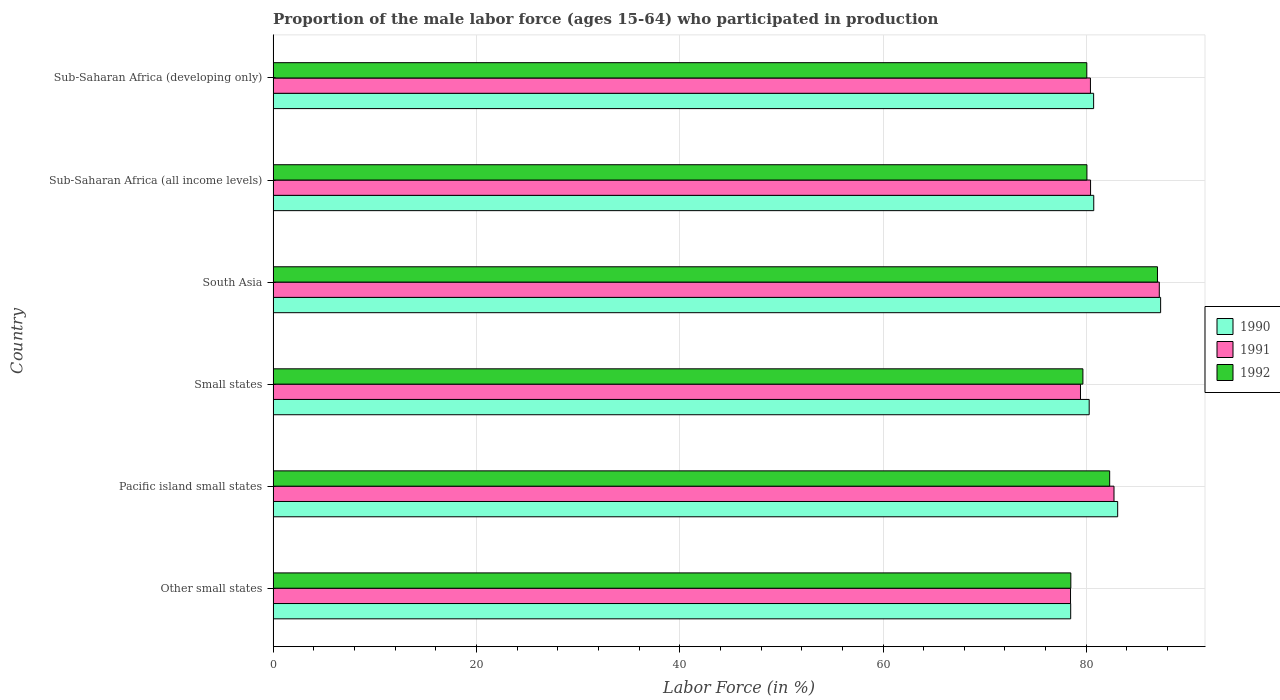How many different coloured bars are there?
Offer a very short reply. 3. Are the number of bars per tick equal to the number of legend labels?
Make the answer very short. Yes. How many bars are there on the 3rd tick from the top?
Offer a very short reply. 3. How many bars are there on the 5th tick from the bottom?
Your response must be concise. 3. What is the label of the 4th group of bars from the top?
Keep it short and to the point. Small states. In how many cases, is the number of bars for a given country not equal to the number of legend labels?
Provide a succinct answer. 0. What is the proportion of the male labor force who participated in production in 1992 in Sub-Saharan Africa (developing only)?
Provide a short and direct response. 80.05. Across all countries, what is the maximum proportion of the male labor force who participated in production in 1990?
Your answer should be compact. 87.31. Across all countries, what is the minimum proportion of the male labor force who participated in production in 1990?
Keep it short and to the point. 78.46. In which country was the proportion of the male labor force who participated in production in 1991 maximum?
Keep it short and to the point. South Asia. In which country was the proportion of the male labor force who participated in production in 1991 minimum?
Offer a terse response. Other small states. What is the total proportion of the male labor force who participated in production in 1992 in the graph?
Give a very brief answer. 487.55. What is the difference between the proportion of the male labor force who participated in production in 1990 in Small states and that in South Asia?
Offer a terse response. -7.03. What is the difference between the proportion of the male labor force who participated in production in 1990 in Pacific island small states and the proportion of the male labor force who participated in production in 1991 in Small states?
Make the answer very short. 3.66. What is the average proportion of the male labor force who participated in production in 1992 per country?
Your answer should be very brief. 81.26. What is the difference between the proportion of the male labor force who participated in production in 1991 and proportion of the male labor force who participated in production in 1992 in Sub-Saharan Africa (all income levels)?
Ensure brevity in your answer.  0.36. In how many countries, is the proportion of the male labor force who participated in production in 1992 greater than 36 %?
Ensure brevity in your answer.  6. What is the ratio of the proportion of the male labor force who participated in production in 1991 in Small states to that in South Asia?
Provide a succinct answer. 0.91. What is the difference between the highest and the second highest proportion of the male labor force who participated in production in 1990?
Make the answer very short. 4.22. What is the difference between the highest and the lowest proportion of the male labor force who participated in production in 1992?
Make the answer very short. 8.52. In how many countries, is the proportion of the male labor force who participated in production in 1992 greater than the average proportion of the male labor force who participated in production in 1992 taken over all countries?
Offer a terse response. 2. Is the sum of the proportion of the male labor force who participated in production in 1991 in Sub-Saharan Africa (all income levels) and Sub-Saharan Africa (developing only) greater than the maximum proportion of the male labor force who participated in production in 1992 across all countries?
Offer a terse response. Yes. What does the 2nd bar from the top in Sub-Saharan Africa (developing only) represents?
Make the answer very short. 1991. What does the 3rd bar from the bottom in Sub-Saharan Africa (developing only) represents?
Make the answer very short. 1992. How many bars are there?
Keep it short and to the point. 18. How many countries are there in the graph?
Give a very brief answer. 6. What is the difference between two consecutive major ticks on the X-axis?
Ensure brevity in your answer.  20. Are the values on the major ticks of X-axis written in scientific E-notation?
Your answer should be compact. No. Does the graph contain any zero values?
Offer a terse response. No. Does the graph contain grids?
Make the answer very short. Yes. What is the title of the graph?
Ensure brevity in your answer.  Proportion of the male labor force (ages 15-64) who participated in production. Does "1974" appear as one of the legend labels in the graph?
Offer a terse response. No. What is the label or title of the X-axis?
Offer a terse response. Labor Force (in %). What is the label or title of the Y-axis?
Your response must be concise. Country. What is the Labor Force (in %) in 1990 in Other small states?
Make the answer very short. 78.46. What is the Labor Force (in %) of 1991 in Other small states?
Provide a short and direct response. 78.45. What is the Labor Force (in %) of 1992 in Other small states?
Your answer should be very brief. 78.48. What is the Labor Force (in %) of 1990 in Pacific island small states?
Offer a very short reply. 83.09. What is the Labor Force (in %) in 1991 in Pacific island small states?
Your answer should be compact. 82.72. What is the Labor Force (in %) in 1992 in Pacific island small states?
Keep it short and to the point. 82.3. What is the Labor Force (in %) of 1990 in Small states?
Offer a terse response. 80.28. What is the Labor Force (in %) of 1991 in Small states?
Your answer should be compact. 79.43. What is the Labor Force (in %) in 1992 in Small states?
Offer a very short reply. 79.66. What is the Labor Force (in %) of 1990 in South Asia?
Your answer should be very brief. 87.31. What is the Labor Force (in %) of 1991 in South Asia?
Offer a terse response. 87.18. What is the Labor Force (in %) in 1992 in South Asia?
Your answer should be compact. 87. What is the Labor Force (in %) of 1990 in Sub-Saharan Africa (all income levels)?
Provide a succinct answer. 80.73. What is the Labor Force (in %) of 1991 in Sub-Saharan Africa (all income levels)?
Your answer should be very brief. 80.42. What is the Labor Force (in %) of 1992 in Sub-Saharan Africa (all income levels)?
Offer a terse response. 80.06. What is the Labor Force (in %) in 1990 in Sub-Saharan Africa (developing only)?
Ensure brevity in your answer.  80.72. What is the Labor Force (in %) in 1991 in Sub-Saharan Africa (developing only)?
Offer a terse response. 80.41. What is the Labor Force (in %) of 1992 in Sub-Saharan Africa (developing only)?
Give a very brief answer. 80.05. Across all countries, what is the maximum Labor Force (in %) of 1990?
Give a very brief answer. 87.31. Across all countries, what is the maximum Labor Force (in %) in 1991?
Ensure brevity in your answer.  87.18. Across all countries, what is the maximum Labor Force (in %) of 1992?
Your answer should be very brief. 87. Across all countries, what is the minimum Labor Force (in %) in 1990?
Ensure brevity in your answer.  78.46. Across all countries, what is the minimum Labor Force (in %) of 1991?
Offer a terse response. 78.45. Across all countries, what is the minimum Labor Force (in %) in 1992?
Your answer should be very brief. 78.48. What is the total Labor Force (in %) in 1990 in the graph?
Provide a short and direct response. 490.6. What is the total Labor Force (in %) in 1991 in the graph?
Make the answer very short. 488.6. What is the total Labor Force (in %) of 1992 in the graph?
Offer a terse response. 487.55. What is the difference between the Labor Force (in %) of 1990 in Other small states and that in Pacific island small states?
Offer a terse response. -4.62. What is the difference between the Labor Force (in %) in 1991 in Other small states and that in Pacific island small states?
Your answer should be compact. -4.28. What is the difference between the Labor Force (in %) in 1992 in Other small states and that in Pacific island small states?
Provide a short and direct response. -3.82. What is the difference between the Labor Force (in %) in 1990 in Other small states and that in Small states?
Your answer should be very brief. -1.82. What is the difference between the Labor Force (in %) of 1991 in Other small states and that in Small states?
Provide a succinct answer. -0.98. What is the difference between the Labor Force (in %) in 1992 in Other small states and that in Small states?
Provide a succinct answer. -1.19. What is the difference between the Labor Force (in %) of 1990 in Other small states and that in South Asia?
Provide a short and direct response. -8.85. What is the difference between the Labor Force (in %) in 1991 in Other small states and that in South Asia?
Provide a short and direct response. -8.73. What is the difference between the Labor Force (in %) in 1992 in Other small states and that in South Asia?
Offer a very short reply. -8.52. What is the difference between the Labor Force (in %) in 1990 in Other small states and that in Sub-Saharan Africa (all income levels)?
Provide a short and direct response. -2.27. What is the difference between the Labor Force (in %) of 1991 in Other small states and that in Sub-Saharan Africa (all income levels)?
Your answer should be very brief. -1.97. What is the difference between the Labor Force (in %) in 1992 in Other small states and that in Sub-Saharan Africa (all income levels)?
Your answer should be compact. -1.58. What is the difference between the Labor Force (in %) in 1990 in Other small states and that in Sub-Saharan Africa (developing only)?
Provide a short and direct response. -2.26. What is the difference between the Labor Force (in %) in 1991 in Other small states and that in Sub-Saharan Africa (developing only)?
Make the answer very short. -1.96. What is the difference between the Labor Force (in %) of 1992 in Other small states and that in Sub-Saharan Africa (developing only)?
Keep it short and to the point. -1.57. What is the difference between the Labor Force (in %) in 1990 in Pacific island small states and that in Small states?
Offer a very short reply. 2.8. What is the difference between the Labor Force (in %) of 1991 in Pacific island small states and that in Small states?
Your response must be concise. 3.3. What is the difference between the Labor Force (in %) in 1992 in Pacific island small states and that in Small states?
Make the answer very short. 2.63. What is the difference between the Labor Force (in %) of 1990 in Pacific island small states and that in South Asia?
Your response must be concise. -4.22. What is the difference between the Labor Force (in %) in 1991 in Pacific island small states and that in South Asia?
Offer a terse response. -4.46. What is the difference between the Labor Force (in %) of 1992 in Pacific island small states and that in South Asia?
Provide a succinct answer. -4.7. What is the difference between the Labor Force (in %) of 1990 in Pacific island small states and that in Sub-Saharan Africa (all income levels)?
Make the answer very short. 2.35. What is the difference between the Labor Force (in %) in 1991 in Pacific island small states and that in Sub-Saharan Africa (all income levels)?
Your answer should be compact. 2.31. What is the difference between the Labor Force (in %) in 1992 in Pacific island small states and that in Sub-Saharan Africa (all income levels)?
Ensure brevity in your answer.  2.24. What is the difference between the Labor Force (in %) of 1990 in Pacific island small states and that in Sub-Saharan Africa (developing only)?
Make the answer very short. 2.37. What is the difference between the Labor Force (in %) in 1991 in Pacific island small states and that in Sub-Saharan Africa (developing only)?
Your response must be concise. 2.32. What is the difference between the Labor Force (in %) in 1992 in Pacific island small states and that in Sub-Saharan Africa (developing only)?
Ensure brevity in your answer.  2.25. What is the difference between the Labor Force (in %) of 1990 in Small states and that in South Asia?
Give a very brief answer. -7.03. What is the difference between the Labor Force (in %) of 1991 in Small states and that in South Asia?
Ensure brevity in your answer.  -7.75. What is the difference between the Labor Force (in %) of 1992 in Small states and that in South Asia?
Give a very brief answer. -7.34. What is the difference between the Labor Force (in %) of 1990 in Small states and that in Sub-Saharan Africa (all income levels)?
Your answer should be compact. -0.45. What is the difference between the Labor Force (in %) of 1991 in Small states and that in Sub-Saharan Africa (all income levels)?
Your response must be concise. -0.99. What is the difference between the Labor Force (in %) in 1992 in Small states and that in Sub-Saharan Africa (all income levels)?
Offer a terse response. -0.4. What is the difference between the Labor Force (in %) in 1990 in Small states and that in Sub-Saharan Africa (developing only)?
Offer a terse response. -0.44. What is the difference between the Labor Force (in %) in 1991 in Small states and that in Sub-Saharan Africa (developing only)?
Give a very brief answer. -0.98. What is the difference between the Labor Force (in %) in 1992 in Small states and that in Sub-Saharan Africa (developing only)?
Your response must be concise. -0.38. What is the difference between the Labor Force (in %) of 1990 in South Asia and that in Sub-Saharan Africa (all income levels)?
Give a very brief answer. 6.58. What is the difference between the Labor Force (in %) in 1991 in South Asia and that in Sub-Saharan Africa (all income levels)?
Your response must be concise. 6.76. What is the difference between the Labor Force (in %) of 1992 in South Asia and that in Sub-Saharan Africa (all income levels)?
Ensure brevity in your answer.  6.94. What is the difference between the Labor Force (in %) in 1990 in South Asia and that in Sub-Saharan Africa (developing only)?
Make the answer very short. 6.59. What is the difference between the Labor Force (in %) in 1991 in South Asia and that in Sub-Saharan Africa (developing only)?
Give a very brief answer. 6.77. What is the difference between the Labor Force (in %) of 1992 in South Asia and that in Sub-Saharan Africa (developing only)?
Offer a terse response. 6.95. What is the difference between the Labor Force (in %) of 1990 in Sub-Saharan Africa (all income levels) and that in Sub-Saharan Africa (developing only)?
Your answer should be compact. 0.01. What is the difference between the Labor Force (in %) of 1991 in Sub-Saharan Africa (all income levels) and that in Sub-Saharan Africa (developing only)?
Make the answer very short. 0.01. What is the difference between the Labor Force (in %) in 1992 in Sub-Saharan Africa (all income levels) and that in Sub-Saharan Africa (developing only)?
Ensure brevity in your answer.  0.01. What is the difference between the Labor Force (in %) in 1990 in Other small states and the Labor Force (in %) in 1991 in Pacific island small states?
Keep it short and to the point. -4.26. What is the difference between the Labor Force (in %) in 1990 in Other small states and the Labor Force (in %) in 1992 in Pacific island small states?
Give a very brief answer. -3.83. What is the difference between the Labor Force (in %) in 1991 in Other small states and the Labor Force (in %) in 1992 in Pacific island small states?
Keep it short and to the point. -3.85. What is the difference between the Labor Force (in %) in 1990 in Other small states and the Labor Force (in %) in 1991 in Small states?
Provide a succinct answer. -0.96. What is the difference between the Labor Force (in %) in 1990 in Other small states and the Labor Force (in %) in 1992 in Small states?
Give a very brief answer. -1.2. What is the difference between the Labor Force (in %) of 1991 in Other small states and the Labor Force (in %) of 1992 in Small states?
Offer a terse response. -1.22. What is the difference between the Labor Force (in %) in 1990 in Other small states and the Labor Force (in %) in 1991 in South Asia?
Provide a short and direct response. -8.72. What is the difference between the Labor Force (in %) in 1990 in Other small states and the Labor Force (in %) in 1992 in South Asia?
Provide a succinct answer. -8.54. What is the difference between the Labor Force (in %) of 1991 in Other small states and the Labor Force (in %) of 1992 in South Asia?
Your response must be concise. -8.55. What is the difference between the Labor Force (in %) in 1990 in Other small states and the Labor Force (in %) in 1991 in Sub-Saharan Africa (all income levels)?
Provide a succinct answer. -1.96. What is the difference between the Labor Force (in %) of 1990 in Other small states and the Labor Force (in %) of 1992 in Sub-Saharan Africa (all income levels)?
Offer a very short reply. -1.6. What is the difference between the Labor Force (in %) in 1991 in Other small states and the Labor Force (in %) in 1992 in Sub-Saharan Africa (all income levels)?
Provide a succinct answer. -1.61. What is the difference between the Labor Force (in %) in 1990 in Other small states and the Labor Force (in %) in 1991 in Sub-Saharan Africa (developing only)?
Give a very brief answer. -1.94. What is the difference between the Labor Force (in %) of 1990 in Other small states and the Labor Force (in %) of 1992 in Sub-Saharan Africa (developing only)?
Provide a succinct answer. -1.58. What is the difference between the Labor Force (in %) in 1991 in Other small states and the Labor Force (in %) in 1992 in Sub-Saharan Africa (developing only)?
Provide a succinct answer. -1.6. What is the difference between the Labor Force (in %) of 1990 in Pacific island small states and the Labor Force (in %) of 1991 in Small states?
Provide a short and direct response. 3.66. What is the difference between the Labor Force (in %) of 1990 in Pacific island small states and the Labor Force (in %) of 1992 in Small states?
Your response must be concise. 3.42. What is the difference between the Labor Force (in %) of 1991 in Pacific island small states and the Labor Force (in %) of 1992 in Small states?
Provide a short and direct response. 3.06. What is the difference between the Labor Force (in %) of 1990 in Pacific island small states and the Labor Force (in %) of 1991 in South Asia?
Your answer should be very brief. -4.09. What is the difference between the Labor Force (in %) in 1990 in Pacific island small states and the Labor Force (in %) in 1992 in South Asia?
Ensure brevity in your answer.  -3.91. What is the difference between the Labor Force (in %) in 1991 in Pacific island small states and the Labor Force (in %) in 1992 in South Asia?
Make the answer very short. -4.28. What is the difference between the Labor Force (in %) in 1990 in Pacific island small states and the Labor Force (in %) in 1991 in Sub-Saharan Africa (all income levels)?
Your answer should be very brief. 2.67. What is the difference between the Labor Force (in %) of 1990 in Pacific island small states and the Labor Force (in %) of 1992 in Sub-Saharan Africa (all income levels)?
Offer a very short reply. 3.03. What is the difference between the Labor Force (in %) of 1991 in Pacific island small states and the Labor Force (in %) of 1992 in Sub-Saharan Africa (all income levels)?
Your response must be concise. 2.66. What is the difference between the Labor Force (in %) of 1990 in Pacific island small states and the Labor Force (in %) of 1991 in Sub-Saharan Africa (developing only)?
Offer a very short reply. 2.68. What is the difference between the Labor Force (in %) of 1990 in Pacific island small states and the Labor Force (in %) of 1992 in Sub-Saharan Africa (developing only)?
Offer a terse response. 3.04. What is the difference between the Labor Force (in %) of 1991 in Pacific island small states and the Labor Force (in %) of 1992 in Sub-Saharan Africa (developing only)?
Your answer should be compact. 2.68. What is the difference between the Labor Force (in %) in 1990 in Small states and the Labor Force (in %) in 1991 in South Asia?
Make the answer very short. -6.9. What is the difference between the Labor Force (in %) of 1990 in Small states and the Labor Force (in %) of 1992 in South Asia?
Offer a terse response. -6.72. What is the difference between the Labor Force (in %) in 1991 in Small states and the Labor Force (in %) in 1992 in South Asia?
Keep it short and to the point. -7.57. What is the difference between the Labor Force (in %) of 1990 in Small states and the Labor Force (in %) of 1991 in Sub-Saharan Africa (all income levels)?
Your answer should be compact. -0.14. What is the difference between the Labor Force (in %) in 1990 in Small states and the Labor Force (in %) in 1992 in Sub-Saharan Africa (all income levels)?
Offer a very short reply. 0.22. What is the difference between the Labor Force (in %) of 1991 in Small states and the Labor Force (in %) of 1992 in Sub-Saharan Africa (all income levels)?
Make the answer very short. -0.63. What is the difference between the Labor Force (in %) in 1990 in Small states and the Labor Force (in %) in 1991 in Sub-Saharan Africa (developing only)?
Your answer should be very brief. -0.12. What is the difference between the Labor Force (in %) in 1990 in Small states and the Labor Force (in %) in 1992 in Sub-Saharan Africa (developing only)?
Offer a very short reply. 0.24. What is the difference between the Labor Force (in %) of 1991 in Small states and the Labor Force (in %) of 1992 in Sub-Saharan Africa (developing only)?
Offer a very short reply. -0.62. What is the difference between the Labor Force (in %) in 1990 in South Asia and the Labor Force (in %) in 1991 in Sub-Saharan Africa (all income levels)?
Provide a short and direct response. 6.89. What is the difference between the Labor Force (in %) of 1990 in South Asia and the Labor Force (in %) of 1992 in Sub-Saharan Africa (all income levels)?
Keep it short and to the point. 7.25. What is the difference between the Labor Force (in %) in 1991 in South Asia and the Labor Force (in %) in 1992 in Sub-Saharan Africa (all income levels)?
Your response must be concise. 7.12. What is the difference between the Labor Force (in %) of 1990 in South Asia and the Labor Force (in %) of 1991 in Sub-Saharan Africa (developing only)?
Keep it short and to the point. 6.9. What is the difference between the Labor Force (in %) in 1990 in South Asia and the Labor Force (in %) in 1992 in Sub-Saharan Africa (developing only)?
Your answer should be compact. 7.26. What is the difference between the Labor Force (in %) in 1991 in South Asia and the Labor Force (in %) in 1992 in Sub-Saharan Africa (developing only)?
Ensure brevity in your answer.  7.13. What is the difference between the Labor Force (in %) of 1990 in Sub-Saharan Africa (all income levels) and the Labor Force (in %) of 1991 in Sub-Saharan Africa (developing only)?
Provide a short and direct response. 0.33. What is the difference between the Labor Force (in %) of 1990 in Sub-Saharan Africa (all income levels) and the Labor Force (in %) of 1992 in Sub-Saharan Africa (developing only)?
Offer a terse response. 0.68. What is the difference between the Labor Force (in %) in 1991 in Sub-Saharan Africa (all income levels) and the Labor Force (in %) in 1992 in Sub-Saharan Africa (developing only)?
Provide a succinct answer. 0.37. What is the average Labor Force (in %) of 1990 per country?
Provide a short and direct response. 81.77. What is the average Labor Force (in %) in 1991 per country?
Provide a short and direct response. 81.43. What is the average Labor Force (in %) in 1992 per country?
Offer a terse response. 81.26. What is the difference between the Labor Force (in %) in 1990 and Labor Force (in %) in 1991 in Other small states?
Your answer should be very brief. 0.02. What is the difference between the Labor Force (in %) in 1990 and Labor Force (in %) in 1992 in Other small states?
Offer a very short reply. -0.01. What is the difference between the Labor Force (in %) of 1991 and Labor Force (in %) of 1992 in Other small states?
Provide a succinct answer. -0.03. What is the difference between the Labor Force (in %) of 1990 and Labor Force (in %) of 1991 in Pacific island small states?
Make the answer very short. 0.36. What is the difference between the Labor Force (in %) of 1990 and Labor Force (in %) of 1992 in Pacific island small states?
Your response must be concise. 0.79. What is the difference between the Labor Force (in %) of 1991 and Labor Force (in %) of 1992 in Pacific island small states?
Offer a terse response. 0.43. What is the difference between the Labor Force (in %) in 1990 and Labor Force (in %) in 1991 in Small states?
Provide a succinct answer. 0.86. What is the difference between the Labor Force (in %) in 1990 and Labor Force (in %) in 1992 in Small states?
Offer a very short reply. 0.62. What is the difference between the Labor Force (in %) of 1991 and Labor Force (in %) of 1992 in Small states?
Your answer should be compact. -0.24. What is the difference between the Labor Force (in %) in 1990 and Labor Force (in %) in 1991 in South Asia?
Your answer should be compact. 0.13. What is the difference between the Labor Force (in %) in 1990 and Labor Force (in %) in 1992 in South Asia?
Provide a short and direct response. 0.31. What is the difference between the Labor Force (in %) of 1991 and Labor Force (in %) of 1992 in South Asia?
Your response must be concise. 0.18. What is the difference between the Labor Force (in %) in 1990 and Labor Force (in %) in 1991 in Sub-Saharan Africa (all income levels)?
Provide a short and direct response. 0.31. What is the difference between the Labor Force (in %) in 1990 and Labor Force (in %) in 1992 in Sub-Saharan Africa (all income levels)?
Ensure brevity in your answer.  0.67. What is the difference between the Labor Force (in %) of 1991 and Labor Force (in %) of 1992 in Sub-Saharan Africa (all income levels)?
Provide a succinct answer. 0.36. What is the difference between the Labor Force (in %) in 1990 and Labor Force (in %) in 1991 in Sub-Saharan Africa (developing only)?
Give a very brief answer. 0.31. What is the difference between the Labor Force (in %) in 1990 and Labor Force (in %) in 1992 in Sub-Saharan Africa (developing only)?
Make the answer very short. 0.67. What is the difference between the Labor Force (in %) of 1991 and Labor Force (in %) of 1992 in Sub-Saharan Africa (developing only)?
Give a very brief answer. 0.36. What is the ratio of the Labor Force (in %) of 1990 in Other small states to that in Pacific island small states?
Offer a terse response. 0.94. What is the ratio of the Labor Force (in %) in 1991 in Other small states to that in Pacific island small states?
Your response must be concise. 0.95. What is the ratio of the Labor Force (in %) in 1992 in Other small states to that in Pacific island small states?
Offer a terse response. 0.95. What is the ratio of the Labor Force (in %) of 1990 in Other small states to that in Small states?
Ensure brevity in your answer.  0.98. What is the ratio of the Labor Force (in %) in 1992 in Other small states to that in Small states?
Your response must be concise. 0.99. What is the ratio of the Labor Force (in %) in 1990 in Other small states to that in South Asia?
Your answer should be very brief. 0.9. What is the ratio of the Labor Force (in %) in 1991 in Other small states to that in South Asia?
Give a very brief answer. 0.9. What is the ratio of the Labor Force (in %) of 1992 in Other small states to that in South Asia?
Your response must be concise. 0.9. What is the ratio of the Labor Force (in %) of 1990 in Other small states to that in Sub-Saharan Africa (all income levels)?
Your answer should be very brief. 0.97. What is the ratio of the Labor Force (in %) in 1991 in Other small states to that in Sub-Saharan Africa (all income levels)?
Your answer should be compact. 0.98. What is the ratio of the Labor Force (in %) of 1992 in Other small states to that in Sub-Saharan Africa (all income levels)?
Give a very brief answer. 0.98. What is the ratio of the Labor Force (in %) of 1990 in Other small states to that in Sub-Saharan Africa (developing only)?
Make the answer very short. 0.97. What is the ratio of the Labor Force (in %) of 1991 in Other small states to that in Sub-Saharan Africa (developing only)?
Provide a succinct answer. 0.98. What is the ratio of the Labor Force (in %) of 1992 in Other small states to that in Sub-Saharan Africa (developing only)?
Your response must be concise. 0.98. What is the ratio of the Labor Force (in %) in 1990 in Pacific island small states to that in Small states?
Make the answer very short. 1.03. What is the ratio of the Labor Force (in %) of 1991 in Pacific island small states to that in Small states?
Your answer should be compact. 1.04. What is the ratio of the Labor Force (in %) of 1992 in Pacific island small states to that in Small states?
Your answer should be very brief. 1.03. What is the ratio of the Labor Force (in %) of 1990 in Pacific island small states to that in South Asia?
Give a very brief answer. 0.95. What is the ratio of the Labor Force (in %) in 1991 in Pacific island small states to that in South Asia?
Keep it short and to the point. 0.95. What is the ratio of the Labor Force (in %) in 1992 in Pacific island small states to that in South Asia?
Offer a terse response. 0.95. What is the ratio of the Labor Force (in %) in 1990 in Pacific island small states to that in Sub-Saharan Africa (all income levels)?
Make the answer very short. 1.03. What is the ratio of the Labor Force (in %) of 1991 in Pacific island small states to that in Sub-Saharan Africa (all income levels)?
Provide a short and direct response. 1.03. What is the ratio of the Labor Force (in %) in 1992 in Pacific island small states to that in Sub-Saharan Africa (all income levels)?
Offer a terse response. 1.03. What is the ratio of the Labor Force (in %) in 1990 in Pacific island small states to that in Sub-Saharan Africa (developing only)?
Keep it short and to the point. 1.03. What is the ratio of the Labor Force (in %) in 1991 in Pacific island small states to that in Sub-Saharan Africa (developing only)?
Make the answer very short. 1.03. What is the ratio of the Labor Force (in %) of 1992 in Pacific island small states to that in Sub-Saharan Africa (developing only)?
Your answer should be very brief. 1.03. What is the ratio of the Labor Force (in %) in 1990 in Small states to that in South Asia?
Provide a succinct answer. 0.92. What is the ratio of the Labor Force (in %) of 1991 in Small states to that in South Asia?
Your answer should be compact. 0.91. What is the ratio of the Labor Force (in %) in 1992 in Small states to that in South Asia?
Your answer should be compact. 0.92. What is the ratio of the Labor Force (in %) in 1990 in Small states to that in Sub-Saharan Africa (all income levels)?
Keep it short and to the point. 0.99. What is the ratio of the Labor Force (in %) in 1991 in Small states to that in Sub-Saharan Africa (all income levels)?
Offer a very short reply. 0.99. What is the ratio of the Labor Force (in %) in 1990 in Small states to that in Sub-Saharan Africa (developing only)?
Provide a short and direct response. 0.99. What is the ratio of the Labor Force (in %) of 1991 in Small states to that in Sub-Saharan Africa (developing only)?
Provide a short and direct response. 0.99. What is the ratio of the Labor Force (in %) of 1992 in Small states to that in Sub-Saharan Africa (developing only)?
Give a very brief answer. 1. What is the ratio of the Labor Force (in %) of 1990 in South Asia to that in Sub-Saharan Africa (all income levels)?
Give a very brief answer. 1.08. What is the ratio of the Labor Force (in %) in 1991 in South Asia to that in Sub-Saharan Africa (all income levels)?
Keep it short and to the point. 1.08. What is the ratio of the Labor Force (in %) of 1992 in South Asia to that in Sub-Saharan Africa (all income levels)?
Provide a succinct answer. 1.09. What is the ratio of the Labor Force (in %) of 1990 in South Asia to that in Sub-Saharan Africa (developing only)?
Ensure brevity in your answer.  1.08. What is the ratio of the Labor Force (in %) in 1991 in South Asia to that in Sub-Saharan Africa (developing only)?
Offer a very short reply. 1.08. What is the ratio of the Labor Force (in %) in 1992 in South Asia to that in Sub-Saharan Africa (developing only)?
Ensure brevity in your answer.  1.09. What is the ratio of the Labor Force (in %) in 1990 in Sub-Saharan Africa (all income levels) to that in Sub-Saharan Africa (developing only)?
Provide a succinct answer. 1. What is the ratio of the Labor Force (in %) in 1991 in Sub-Saharan Africa (all income levels) to that in Sub-Saharan Africa (developing only)?
Your response must be concise. 1. What is the difference between the highest and the second highest Labor Force (in %) of 1990?
Your response must be concise. 4.22. What is the difference between the highest and the second highest Labor Force (in %) in 1991?
Provide a short and direct response. 4.46. What is the difference between the highest and the second highest Labor Force (in %) of 1992?
Ensure brevity in your answer.  4.7. What is the difference between the highest and the lowest Labor Force (in %) of 1990?
Your answer should be compact. 8.85. What is the difference between the highest and the lowest Labor Force (in %) of 1991?
Offer a terse response. 8.73. What is the difference between the highest and the lowest Labor Force (in %) of 1992?
Give a very brief answer. 8.52. 